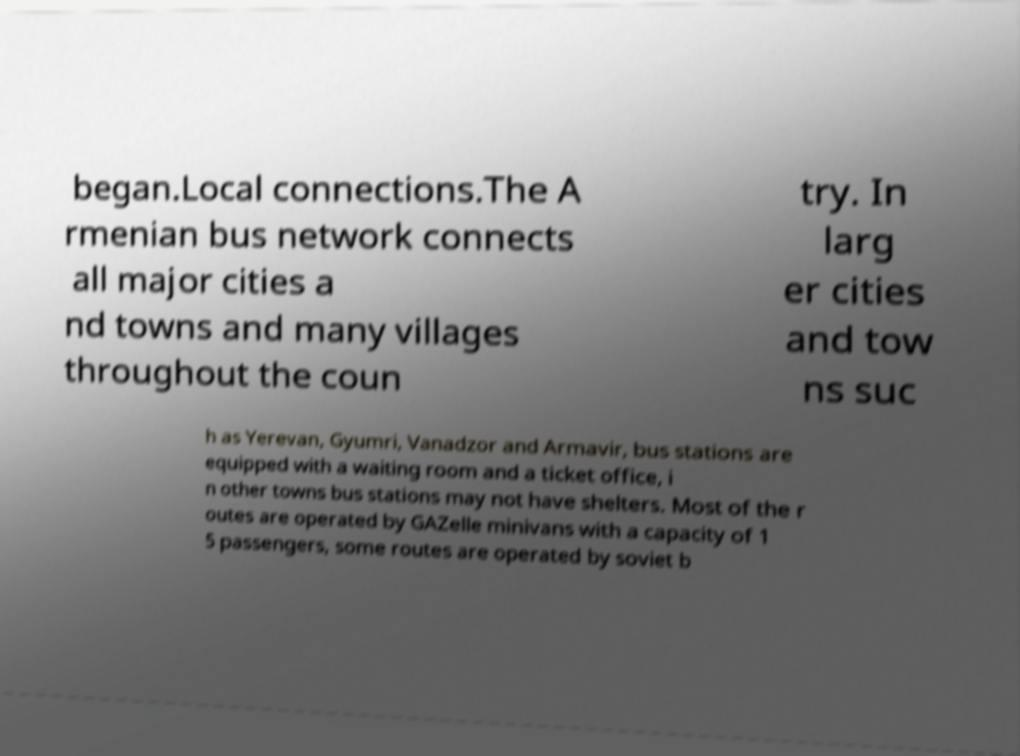Please identify and transcribe the text found in this image. began.Local connections.The A rmenian bus network connects all major cities a nd towns and many villages throughout the coun try. In larg er cities and tow ns suc h as Yerevan, Gyumri, Vanadzor and Armavir, bus stations are equipped with a waiting room and a ticket office, i n other towns bus stations may not have shelters. Most of the r outes are operated by GAZelle minivans with a capacity of 1 5 passengers, some routes are operated by soviet b 